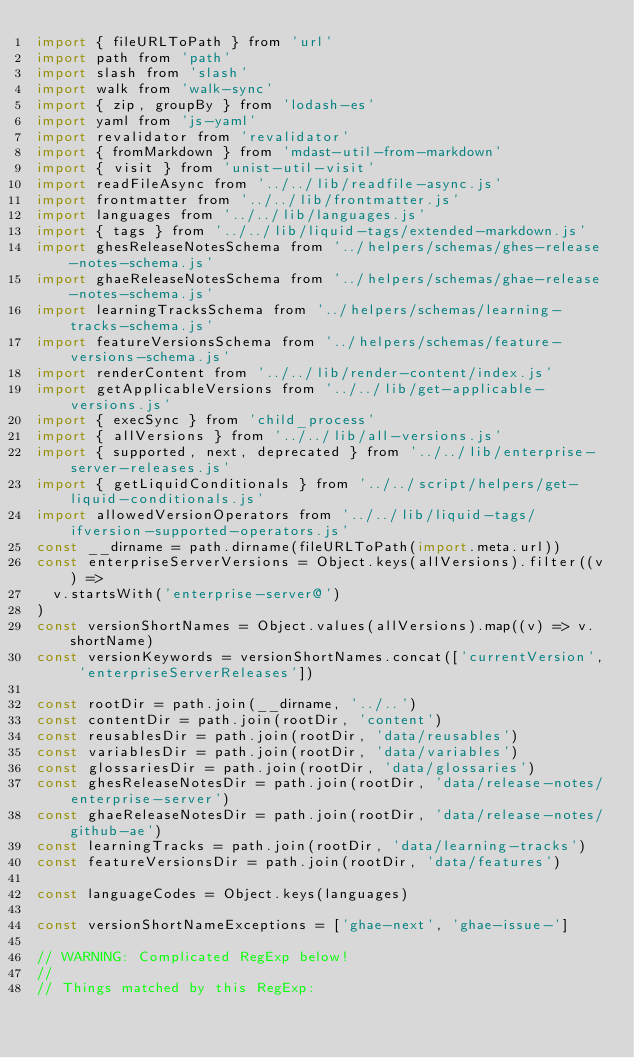<code> <loc_0><loc_0><loc_500><loc_500><_JavaScript_>import { fileURLToPath } from 'url'
import path from 'path'
import slash from 'slash'
import walk from 'walk-sync'
import { zip, groupBy } from 'lodash-es'
import yaml from 'js-yaml'
import revalidator from 'revalidator'
import { fromMarkdown } from 'mdast-util-from-markdown'
import { visit } from 'unist-util-visit'
import readFileAsync from '../../lib/readfile-async.js'
import frontmatter from '../../lib/frontmatter.js'
import languages from '../../lib/languages.js'
import { tags } from '../../lib/liquid-tags/extended-markdown.js'
import ghesReleaseNotesSchema from '../helpers/schemas/ghes-release-notes-schema.js'
import ghaeReleaseNotesSchema from '../helpers/schemas/ghae-release-notes-schema.js'
import learningTracksSchema from '../helpers/schemas/learning-tracks-schema.js'
import featureVersionsSchema from '../helpers/schemas/feature-versions-schema.js'
import renderContent from '../../lib/render-content/index.js'
import getApplicableVersions from '../../lib/get-applicable-versions.js'
import { execSync } from 'child_process'
import { allVersions } from '../../lib/all-versions.js'
import { supported, next, deprecated } from '../../lib/enterprise-server-releases.js'
import { getLiquidConditionals } from '../../script/helpers/get-liquid-conditionals.js'
import allowedVersionOperators from '../../lib/liquid-tags/ifversion-supported-operators.js'
const __dirname = path.dirname(fileURLToPath(import.meta.url))
const enterpriseServerVersions = Object.keys(allVersions).filter((v) =>
  v.startsWith('enterprise-server@')
)
const versionShortNames = Object.values(allVersions).map((v) => v.shortName)
const versionKeywords = versionShortNames.concat(['currentVersion', 'enterpriseServerReleases'])

const rootDir = path.join(__dirname, '../..')
const contentDir = path.join(rootDir, 'content')
const reusablesDir = path.join(rootDir, 'data/reusables')
const variablesDir = path.join(rootDir, 'data/variables')
const glossariesDir = path.join(rootDir, 'data/glossaries')
const ghesReleaseNotesDir = path.join(rootDir, 'data/release-notes/enterprise-server')
const ghaeReleaseNotesDir = path.join(rootDir, 'data/release-notes/github-ae')
const learningTracks = path.join(rootDir, 'data/learning-tracks')
const featureVersionsDir = path.join(rootDir, 'data/features')

const languageCodes = Object.keys(languages)

const versionShortNameExceptions = ['ghae-next', 'ghae-issue-']

// WARNING: Complicated RegExp below!
//
// Things matched by this RegExp:</code> 